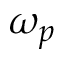<formula> <loc_0><loc_0><loc_500><loc_500>\omega _ { p }</formula> 